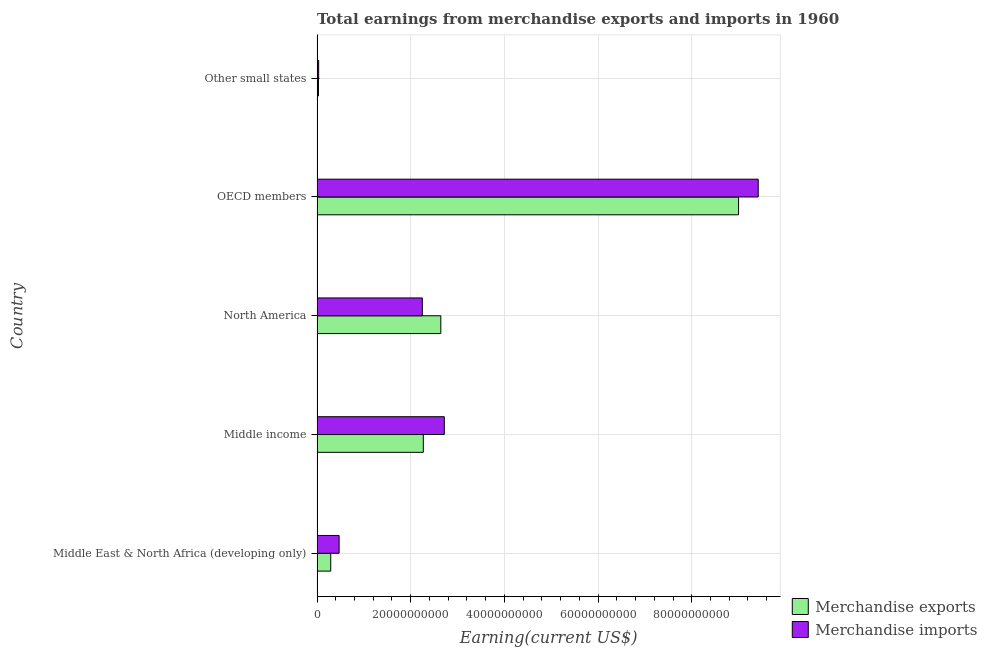How many different coloured bars are there?
Keep it short and to the point. 2. Are the number of bars on each tick of the Y-axis equal?
Ensure brevity in your answer.  Yes. What is the earnings from merchandise imports in Middle East & North Africa (developing only)?
Ensure brevity in your answer.  4.71e+09. Across all countries, what is the maximum earnings from merchandise imports?
Provide a short and direct response. 9.42e+1. Across all countries, what is the minimum earnings from merchandise imports?
Your answer should be compact. 3.42e+08. In which country was the earnings from merchandise imports maximum?
Your answer should be very brief. OECD members. In which country was the earnings from merchandise imports minimum?
Keep it short and to the point. Other small states. What is the total earnings from merchandise exports in the graph?
Your response must be concise. 1.42e+11. What is the difference between the earnings from merchandise imports in Middle East & North Africa (developing only) and that in OECD members?
Your answer should be very brief. -8.95e+1. What is the difference between the earnings from merchandise exports in Middle income and the earnings from merchandise imports in North America?
Ensure brevity in your answer.  2.12e+08. What is the average earnings from merchandise exports per country?
Keep it short and to the point. 2.85e+1. What is the difference between the earnings from merchandise exports and earnings from merchandise imports in Middle income?
Offer a very short reply. -4.48e+09. In how many countries, is the earnings from merchandise imports greater than 92000000000 US$?
Make the answer very short. 1. Is the difference between the earnings from merchandise imports in Middle East & North Africa (developing only) and Middle income greater than the difference between the earnings from merchandise exports in Middle East & North Africa (developing only) and Middle income?
Your answer should be very brief. No. What is the difference between the highest and the second highest earnings from merchandise imports?
Offer a terse response. 6.70e+1. What is the difference between the highest and the lowest earnings from merchandise exports?
Offer a terse response. 8.97e+1. Is the sum of the earnings from merchandise exports in Middle income and OECD members greater than the maximum earnings from merchandise imports across all countries?
Make the answer very short. Yes. What does the 2nd bar from the bottom in Middle income represents?
Keep it short and to the point. Merchandise imports. Are the values on the major ticks of X-axis written in scientific E-notation?
Your answer should be very brief. No. Does the graph contain any zero values?
Offer a terse response. No. Does the graph contain grids?
Offer a very short reply. Yes. Where does the legend appear in the graph?
Give a very brief answer. Bottom right. How are the legend labels stacked?
Ensure brevity in your answer.  Vertical. What is the title of the graph?
Make the answer very short. Total earnings from merchandise exports and imports in 1960. What is the label or title of the X-axis?
Give a very brief answer. Earning(current US$). What is the Earning(current US$) in Merchandise exports in Middle East & North Africa (developing only)?
Ensure brevity in your answer.  2.92e+09. What is the Earning(current US$) of Merchandise imports in Middle East & North Africa (developing only)?
Your answer should be compact. 4.71e+09. What is the Earning(current US$) of Merchandise exports in Middle income?
Provide a succinct answer. 2.27e+1. What is the Earning(current US$) in Merchandise imports in Middle income?
Keep it short and to the point. 2.72e+1. What is the Earning(current US$) of Merchandise exports in North America?
Your answer should be very brief. 2.64e+1. What is the Earning(current US$) in Merchandise imports in North America?
Your answer should be compact. 2.25e+1. What is the Earning(current US$) of Merchandise exports in OECD members?
Keep it short and to the point. 9.00e+1. What is the Earning(current US$) in Merchandise imports in OECD members?
Give a very brief answer. 9.42e+1. What is the Earning(current US$) of Merchandise exports in Other small states?
Offer a very short reply. 2.98e+08. What is the Earning(current US$) of Merchandise imports in Other small states?
Offer a very short reply. 3.42e+08. Across all countries, what is the maximum Earning(current US$) of Merchandise exports?
Your answer should be very brief. 9.00e+1. Across all countries, what is the maximum Earning(current US$) of Merchandise imports?
Provide a short and direct response. 9.42e+1. Across all countries, what is the minimum Earning(current US$) in Merchandise exports?
Ensure brevity in your answer.  2.98e+08. Across all countries, what is the minimum Earning(current US$) of Merchandise imports?
Offer a terse response. 3.42e+08. What is the total Earning(current US$) in Merchandise exports in the graph?
Provide a succinct answer. 1.42e+11. What is the total Earning(current US$) of Merchandise imports in the graph?
Your answer should be compact. 1.49e+11. What is the difference between the Earning(current US$) in Merchandise exports in Middle East & North Africa (developing only) and that in Middle income?
Offer a very short reply. -1.98e+1. What is the difference between the Earning(current US$) in Merchandise imports in Middle East & North Africa (developing only) and that in Middle income?
Your answer should be compact. -2.25e+1. What is the difference between the Earning(current US$) in Merchandise exports in Middle East & North Africa (developing only) and that in North America?
Keep it short and to the point. -2.35e+1. What is the difference between the Earning(current US$) in Merchandise imports in Middle East & North Africa (developing only) and that in North America?
Give a very brief answer. -1.78e+1. What is the difference between the Earning(current US$) of Merchandise exports in Middle East & North Africa (developing only) and that in OECD members?
Provide a short and direct response. -8.71e+1. What is the difference between the Earning(current US$) of Merchandise imports in Middle East & North Africa (developing only) and that in OECD members?
Your response must be concise. -8.95e+1. What is the difference between the Earning(current US$) in Merchandise exports in Middle East & North Africa (developing only) and that in Other small states?
Ensure brevity in your answer.  2.62e+09. What is the difference between the Earning(current US$) in Merchandise imports in Middle East & North Africa (developing only) and that in Other small states?
Give a very brief answer. 4.37e+09. What is the difference between the Earning(current US$) in Merchandise exports in Middle income and that in North America?
Your response must be concise. -3.73e+09. What is the difference between the Earning(current US$) of Merchandise imports in Middle income and that in North America?
Ensure brevity in your answer.  4.69e+09. What is the difference between the Earning(current US$) in Merchandise exports in Middle income and that in OECD members?
Your answer should be compact. -6.73e+1. What is the difference between the Earning(current US$) of Merchandise imports in Middle income and that in OECD members?
Offer a terse response. -6.70e+1. What is the difference between the Earning(current US$) in Merchandise exports in Middle income and that in Other small states?
Your answer should be compact. 2.24e+1. What is the difference between the Earning(current US$) in Merchandise imports in Middle income and that in Other small states?
Your answer should be very brief. 2.68e+1. What is the difference between the Earning(current US$) in Merchandise exports in North America and that in OECD members?
Ensure brevity in your answer.  -6.36e+1. What is the difference between the Earning(current US$) in Merchandise imports in North America and that in OECD members?
Offer a terse response. -7.17e+1. What is the difference between the Earning(current US$) of Merchandise exports in North America and that in Other small states?
Ensure brevity in your answer.  2.61e+1. What is the difference between the Earning(current US$) in Merchandise imports in North America and that in Other small states?
Offer a very short reply. 2.21e+1. What is the difference between the Earning(current US$) of Merchandise exports in OECD members and that in Other small states?
Your answer should be compact. 8.97e+1. What is the difference between the Earning(current US$) of Merchandise imports in OECD members and that in Other small states?
Your answer should be compact. 9.38e+1. What is the difference between the Earning(current US$) in Merchandise exports in Middle East & North Africa (developing only) and the Earning(current US$) in Merchandise imports in Middle income?
Make the answer very short. -2.42e+1. What is the difference between the Earning(current US$) in Merchandise exports in Middle East & North Africa (developing only) and the Earning(current US$) in Merchandise imports in North America?
Your answer should be compact. -1.96e+1. What is the difference between the Earning(current US$) in Merchandise exports in Middle East & North Africa (developing only) and the Earning(current US$) in Merchandise imports in OECD members?
Provide a succinct answer. -9.13e+1. What is the difference between the Earning(current US$) of Merchandise exports in Middle East & North Africa (developing only) and the Earning(current US$) of Merchandise imports in Other small states?
Your response must be concise. 2.58e+09. What is the difference between the Earning(current US$) in Merchandise exports in Middle income and the Earning(current US$) in Merchandise imports in North America?
Your answer should be very brief. 2.12e+08. What is the difference between the Earning(current US$) of Merchandise exports in Middle income and the Earning(current US$) of Merchandise imports in OECD members?
Ensure brevity in your answer.  -7.15e+1. What is the difference between the Earning(current US$) in Merchandise exports in Middle income and the Earning(current US$) in Merchandise imports in Other small states?
Your response must be concise. 2.23e+1. What is the difference between the Earning(current US$) of Merchandise exports in North America and the Earning(current US$) of Merchandise imports in OECD members?
Your answer should be very brief. -6.78e+1. What is the difference between the Earning(current US$) of Merchandise exports in North America and the Earning(current US$) of Merchandise imports in Other small states?
Make the answer very short. 2.61e+1. What is the difference between the Earning(current US$) of Merchandise exports in OECD members and the Earning(current US$) of Merchandise imports in Other small states?
Make the answer very short. 8.97e+1. What is the average Earning(current US$) of Merchandise exports per country?
Give a very brief answer. 2.85e+1. What is the average Earning(current US$) in Merchandise imports per country?
Provide a succinct answer. 2.98e+1. What is the difference between the Earning(current US$) of Merchandise exports and Earning(current US$) of Merchandise imports in Middle East & North Africa (developing only)?
Provide a short and direct response. -1.79e+09. What is the difference between the Earning(current US$) in Merchandise exports and Earning(current US$) in Merchandise imports in Middle income?
Provide a succinct answer. -4.48e+09. What is the difference between the Earning(current US$) in Merchandise exports and Earning(current US$) in Merchandise imports in North America?
Offer a very short reply. 3.95e+09. What is the difference between the Earning(current US$) of Merchandise exports and Earning(current US$) of Merchandise imports in OECD members?
Provide a short and direct response. -4.19e+09. What is the difference between the Earning(current US$) of Merchandise exports and Earning(current US$) of Merchandise imports in Other small states?
Your answer should be very brief. -4.33e+07. What is the ratio of the Earning(current US$) in Merchandise exports in Middle East & North Africa (developing only) to that in Middle income?
Your answer should be compact. 0.13. What is the ratio of the Earning(current US$) of Merchandise imports in Middle East & North Africa (developing only) to that in Middle income?
Provide a succinct answer. 0.17. What is the ratio of the Earning(current US$) in Merchandise exports in Middle East & North Africa (developing only) to that in North America?
Offer a terse response. 0.11. What is the ratio of the Earning(current US$) of Merchandise imports in Middle East & North Africa (developing only) to that in North America?
Provide a short and direct response. 0.21. What is the ratio of the Earning(current US$) in Merchandise exports in Middle East & North Africa (developing only) to that in OECD members?
Keep it short and to the point. 0.03. What is the ratio of the Earning(current US$) in Merchandise imports in Middle East & North Africa (developing only) to that in OECD members?
Ensure brevity in your answer.  0.05. What is the ratio of the Earning(current US$) of Merchandise exports in Middle East & North Africa (developing only) to that in Other small states?
Your answer should be compact. 9.79. What is the ratio of the Earning(current US$) in Merchandise imports in Middle East & North Africa (developing only) to that in Other small states?
Offer a terse response. 13.79. What is the ratio of the Earning(current US$) of Merchandise exports in Middle income to that in North America?
Offer a terse response. 0.86. What is the ratio of the Earning(current US$) in Merchandise imports in Middle income to that in North America?
Your response must be concise. 1.21. What is the ratio of the Earning(current US$) of Merchandise exports in Middle income to that in OECD members?
Keep it short and to the point. 0.25. What is the ratio of the Earning(current US$) of Merchandise imports in Middle income to that in OECD members?
Ensure brevity in your answer.  0.29. What is the ratio of the Earning(current US$) of Merchandise exports in Middle income to that in Other small states?
Provide a succinct answer. 76.03. What is the ratio of the Earning(current US$) of Merchandise imports in Middle income to that in Other small states?
Give a very brief answer. 79.51. What is the ratio of the Earning(current US$) in Merchandise exports in North America to that in OECD members?
Provide a succinct answer. 0.29. What is the ratio of the Earning(current US$) of Merchandise imports in North America to that in OECD members?
Your response must be concise. 0.24. What is the ratio of the Earning(current US$) of Merchandise exports in North America to that in Other small states?
Your answer should be very brief. 88.55. What is the ratio of the Earning(current US$) of Merchandise imports in North America to that in Other small states?
Give a very brief answer. 65.77. What is the ratio of the Earning(current US$) of Merchandise exports in OECD members to that in Other small states?
Ensure brevity in your answer.  301.6. What is the ratio of the Earning(current US$) of Merchandise imports in OECD members to that in Other small states?
Your answer should be compact. 275.63. What is the difference between the highest and the second highest Earning(current US$) in Merchandise exports?
Keep it short and to the point. 6.36e+1. What is the difference between the highest and the second highest Earning(current US$) in Merchandise imports?
Your response must be concise. 6.70e+1. What is the difference between the highest and the lowest Earning(current US$) of Merchandise exports?
Ensure brevity in your answer.  8.97e+1. What is the difference between the highest and the lowest Earning(current US$) of Merchandise imports?
Offer a very short reply. 9.38e+1. 